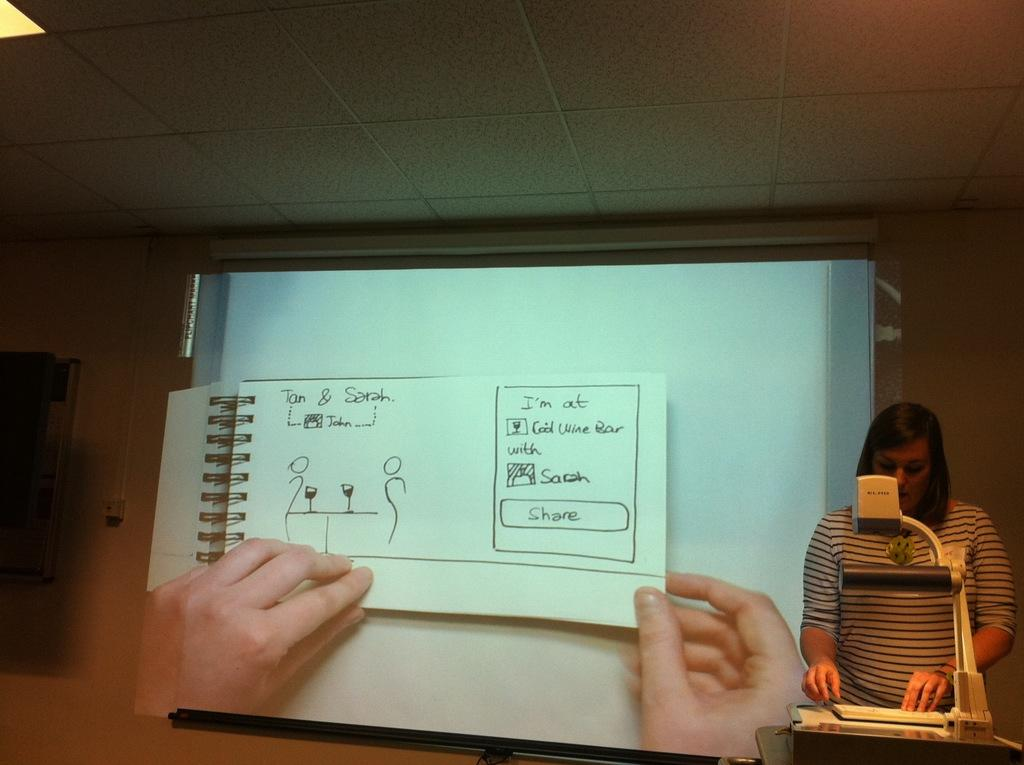Provide a one-sentence caption for the provided image. A spiral book with a page with "Tan & Sarah" on the upper left side. 